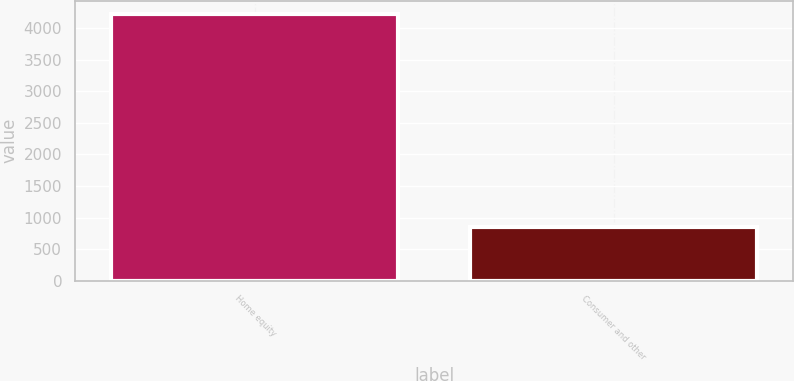Convert chart to OTSL. <chart><loc_0><loc_0><loc_500><loc_500><bar_chart><fcel>Home equity<fcel>Consumer and other<nl><fcel>4223.4<fcel>844.9<nl></chart> 